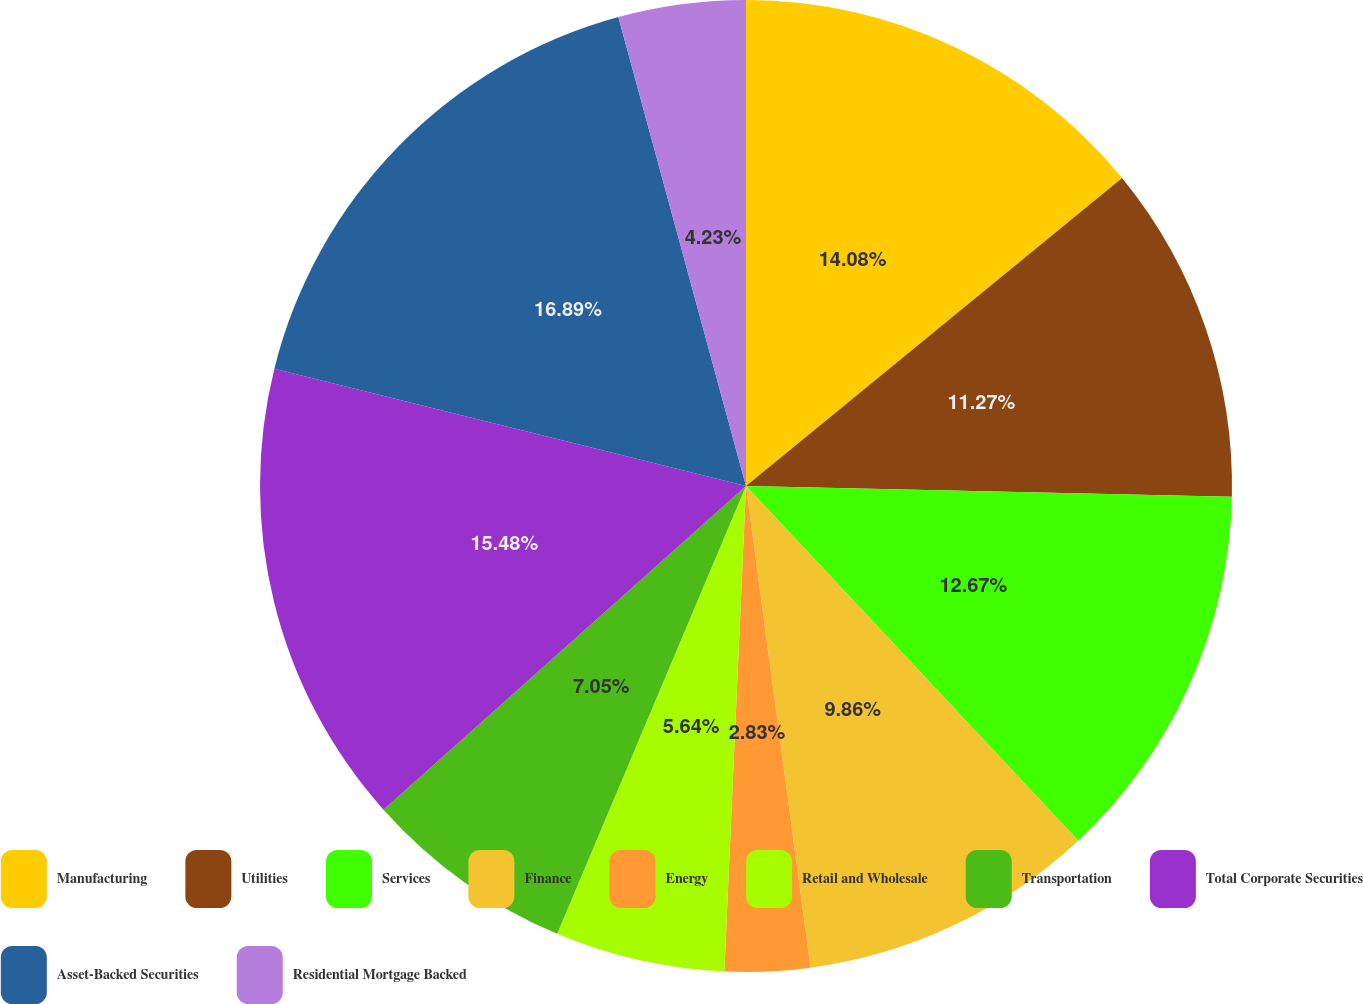Convert chart to OTSL. <chart><loc_0><loc_0><loc_500><loc_500><pie_chart><fcel>Manufacturing<fcel>Utilities<fcel>Services<fcel>Finance<fcel>Energy<fcel>Retail and Wholesale<fcel>Transportation<fcel>Total Corporate Securities<fcel>Asset-Backed Securities<fcel>Residential Mortgage Backed<nl><fcel>14.08%<fcel>11.27%<fcel>12.67%<fcel>9.86%<fcel>2.83%<fcel>5.64%<fcel>7.05%<fcel>15.48%<fcel>16.89%<fcel>4.23%<nl></chart> 